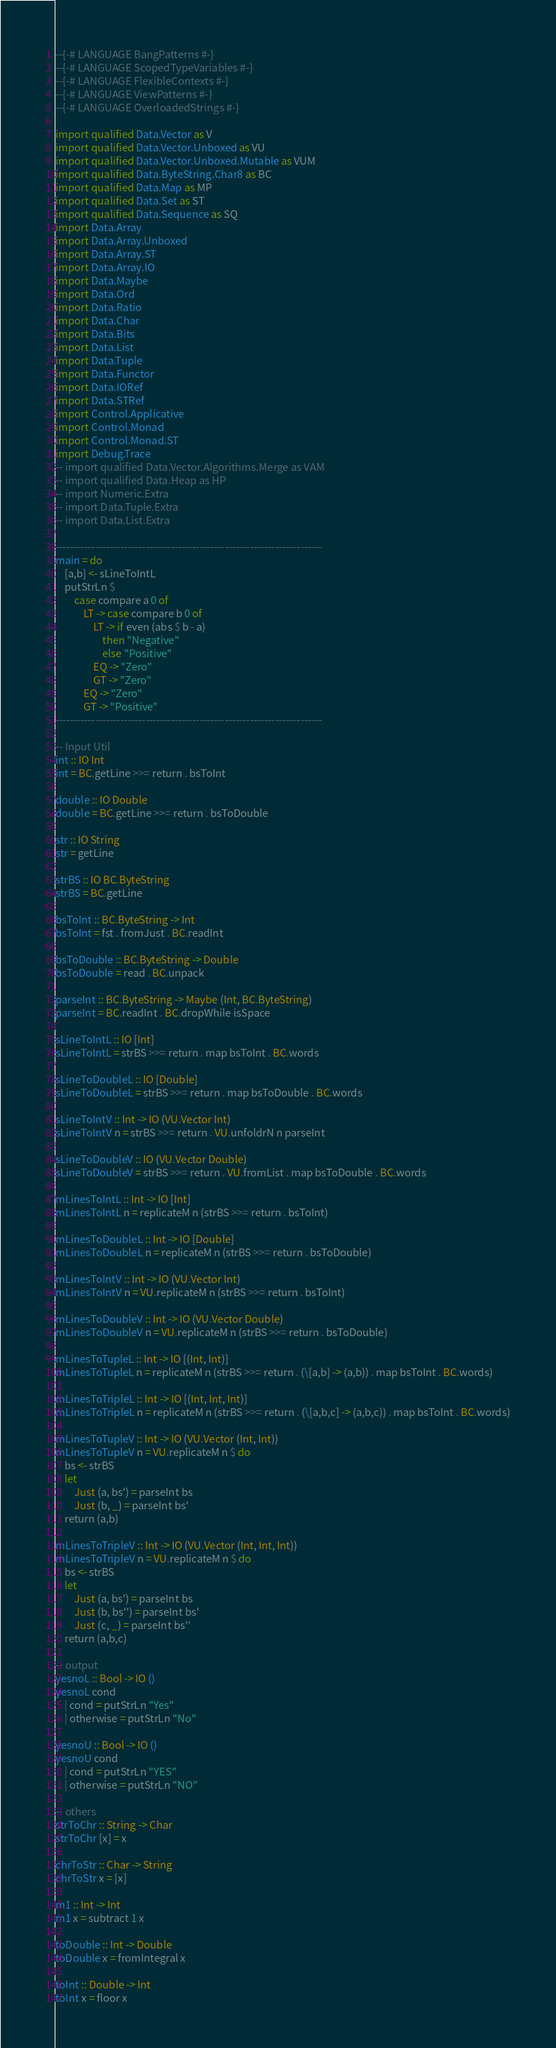<code> <loc_0><loc_0><loc_500><loc_500><_Haskell_>--{-# LANGUAGE BangPatterns #-}
--{-# LANGUAGE ScopedTypeVariables #-}
--{-# LANGUAGE FlexibleContexts #-}
--{-# LANGUAGE ViewPatterns #-}
--{-# LANGUAGE OverloadedStrings #-}

import qualified Data.Vector as V
import qualified Data.Vector.Unboxed as VU
import qualified Data.Vector.Unboxed.Mutable as VUM
import qualified Data.ByteString.Char8 as BC
import qualified Data.Map as MP
import qualified Data.Set as ST
import qualified Data.Sequence as SQ
import Data.Array
import Data.Array.Unboxed
import Data.Array.ST
import Data.Array.IO
import Data.Maybe
import Data.Ord
import Data.Ratio
import Data.Char
import Data.Bits
import Data.List
import Data.Tuple
import Data.Functor
import Data.IORef
import Data.STRef
import Control.Applicative
import Control.Monad
import Control.Monad.ST
import Debug.Trace
-- import qualified Data.Vector.Algorithms.Merge as VAM
-- import qualified Data.Heap as HP
-- import Numeric.Extra
-- import Data.Tuple.Extra
-- import Data.List.Extra

--------------------------------------------------------------------------
main = do
    [a,b] <- sLineToIntL
    putStrLn $ 
        case compare a 0 of
            LT -> case compare b 0 of 
                LT -> if even (abs $ b - a)
                    then "Negative"
                    else "Positive"
                EQ -> "Zero"
                GT -> "Zero"
            EQ -> "Zero"
            GT -> "Positive" 
--------------------------------------------------------------------------

-- Input Util
int :: IO Int
int = BC.getLine >>= return . bsToInt

double :: IO Double
double = BC.getLine >>= return . bsToDouble

str :: IO String
str = getLine

strBS :: IO BC.ByteString
strBS = BC.getLine

bsToInt :: BC.ByteString -> Int
bsToInt = fst . fromJust . BC.readInt

bsToDouble :: BC.ByteString -> Double
bsToDouble = read . BC.unpack

parseInt :: BC.ByteString -> Maybe (Int, BC.ByteString)
parseInt = BC.readInt . BC.dropWhile isSpace

sLineToIntL :: IO [Int]
sLineToIntL = strBS >>= return . map bsToInt . BC.words

sLineToDoubleL :: IO [Double]
sLineToDoubleL = strBS >>= return . map bsToDouble . BC.words

sLineToIntV :: Int -> IO (VU.Vector Int)
sLineToIntV n = strBS >>= return . VU.unfoldrN n parseInt

sLineToDoubleV :: IO (VU.Vector Double)
sLineToDoubleV = strBS >>= return . VU.fromList . map bsToDouble . BC.words

mLinesToIntL :: Int -> IO [Int]
mLinesToIntL n = replicateM n (strBS >>= return . bsToInt)

mLinesToDoubleL :: Int -> IO [Double]
mLinesToDoubleL n = replicateM n (strBS >>= return . bsToDouble)

mLinesToIntV :: Int -> IO (VU.Vector Int)
mLinesToIntV n = VU.replicateM n (strBS >>= return . bsToInt)

mLinesToDoubleV :: Int -> IO (VU.Vector Double)
mLinesToDoubleV n = VU.replicateM n (strBS >>= return . bsToDouble)

mLinesToTupleL :: Int -> IO [(Int, Int)]
mLinesToTupleL n = replicateM n (strBS >>= return . (\[a,b] -> (a,b)) . map bsToInt . BC.words)

mLinesToTripleL :: Int -> IO [(Int, Int, Int)]
mLinesToTripleL n = replicateM n (strBS >>= return . (\[a,b,c] -> (a,b,c)) . map bsToInt . BC.words)

mLinesToTupleV :: Int -> IO (VU.Vector (Int, Int))
mLinesToTupleV n = VU.replicateM n $ do
    bs <- strBS
    let
        Just (a, bs') = parseInt bs
        Just (b, _) = parseInt bs'
    return (a,b)
    
mLinesToTripleV :: Int -> IO (VU.Vector (Int, Int, Int))
mLinesToTripleV n = VU.replicateM n $ do
    bs <- strBS
    let
        Just (a, bs') = parseInt bs
        Just (b, bs'') = parseInt bs'
        Just (c, _) = parseInt bs''
    return (a,b,c)

-- output
yesnoL :: Bool -> IO ()
yesnoL cond
    | cond = putStrLn "Yes"
    | otherwise = putStrLn "No"

yesnoU :: Bool -> IO ()
yesnoU cond
    | cond = putStrLn "YES"
    | otherwise = putStrLn "NO"

-- others
strToChr :: String -> Char
strToChr [x] = x

chrToStr :: Char -> String
chrToStr x = [x]

m1 :: Int -> Int
m1 x = subtract 1 x

toDouble :: Int -> Double
toDouble x = fromIntegral x

toInt :: Double -> Int
toInt x = floor x
</code> 